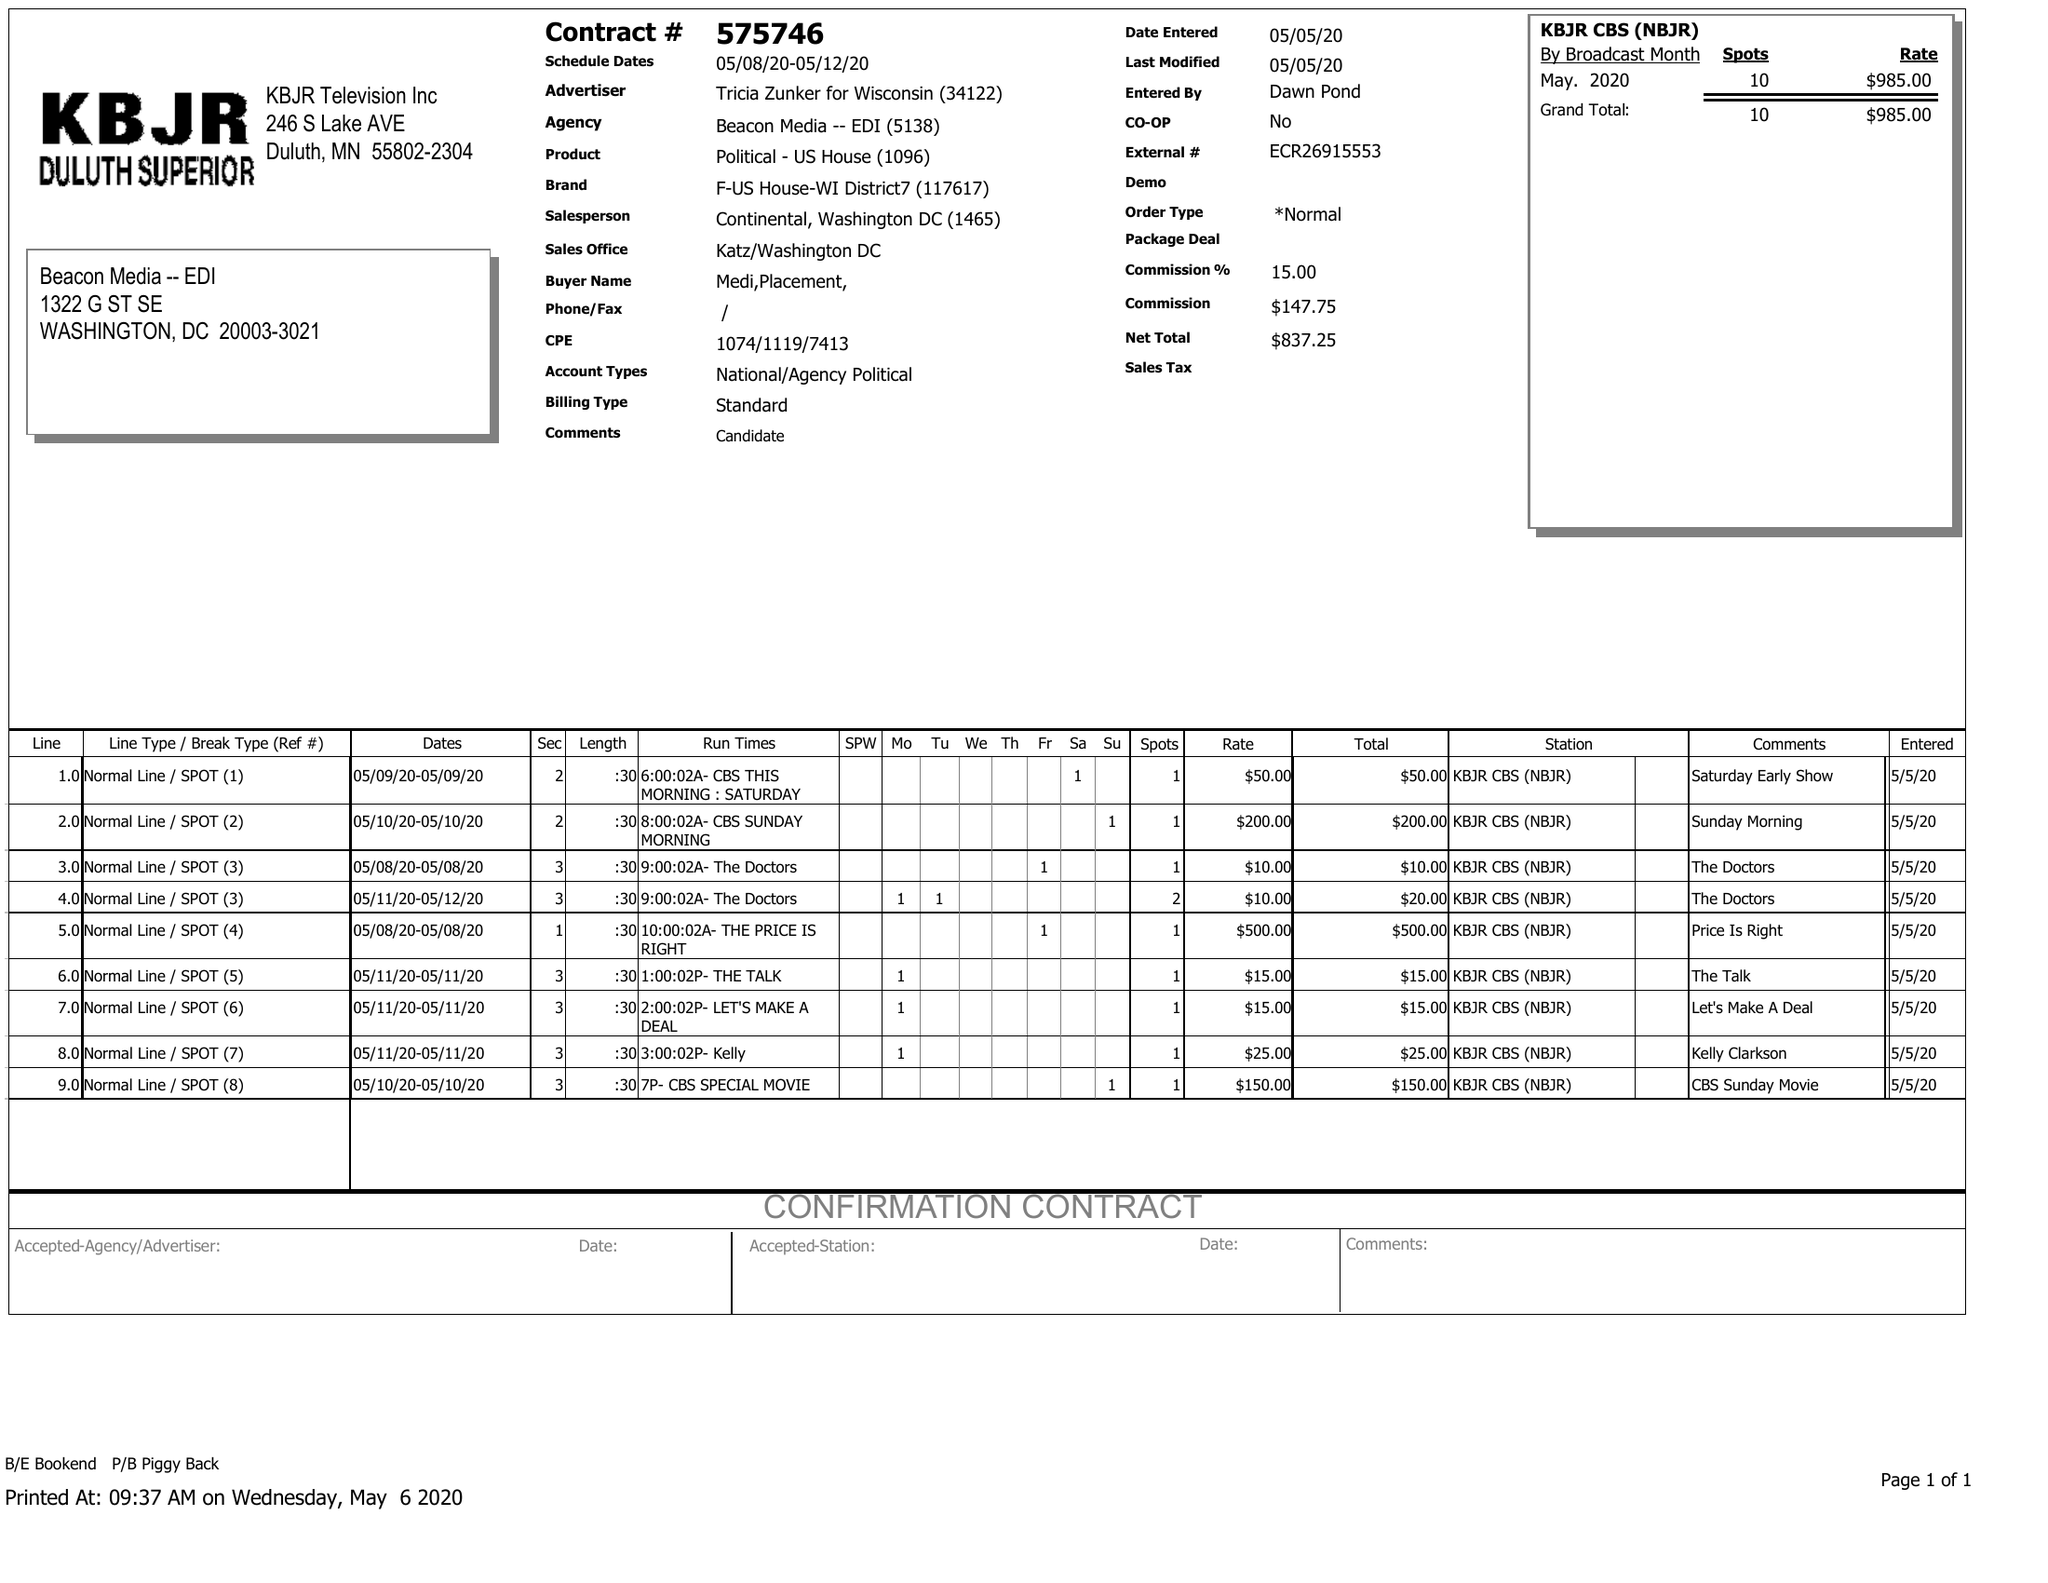What is the value for the flight_to?
Answer the question using a single word or phrase. 05/12/20 